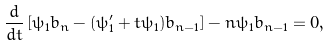<formula> <loc_0><loc_0><loc_500><loc_500>\frac { d } { d t } \left [ \psi _ { 1 } b _ { n } - ( \psi _ { 1 } ^ { \prime } + t \psi _ { 1 } ) b _ { n - 1 } \right ] - n \psi _ { 1 } b _ { n - 1 } = 0 ,</formula> 